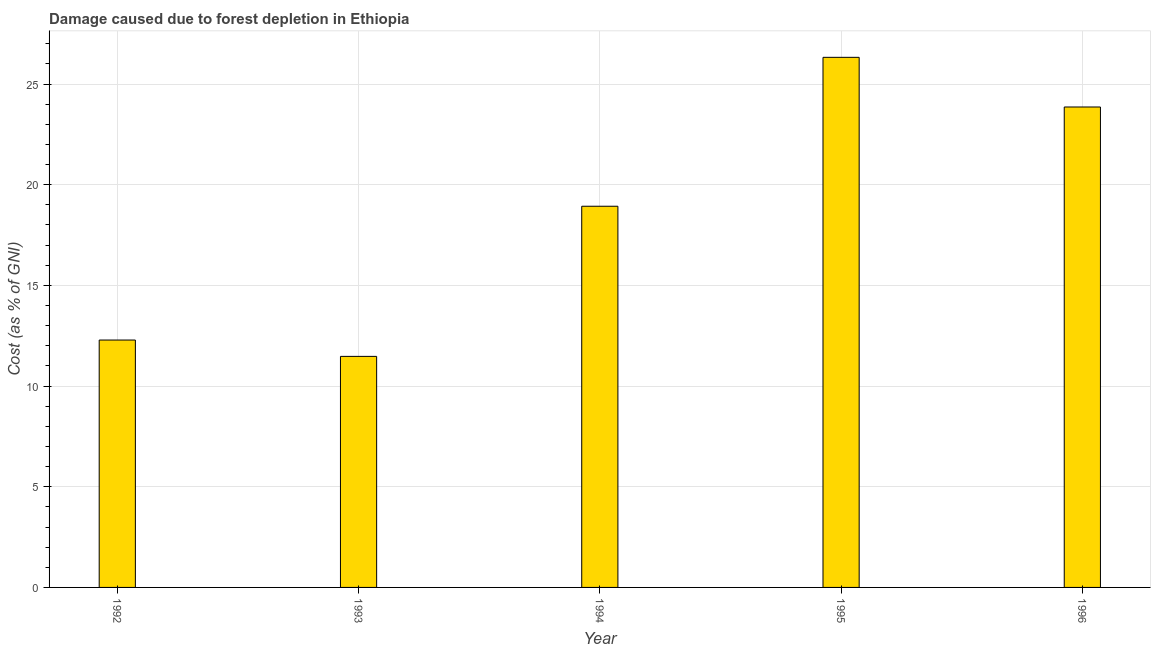Does the graph contain grids?
Offer a terse response. Yes. What is the title of the graph?
Ensure brevity in your answer.  Damage caused due to forest depletion in Ethiopia. What is the label or title of the X-axis?
Your response must be concise. Year. What is the label or title of the Y-axis?
Your response must be concise. Cost (as % of GNI). What is the damage caused due to forest depletion in 1995?
Your response must be concise. 26.33. Across all years, what is the maximum damage caused due to forest depletion?
Give a very brief answer. 26.33. Across all years, what is the minimum damage caused due to forest depletion?
Provide a succinct answer. 11.47. In which year was the damage caused due to forest depletion maximum?
Provide a short and direct response. 1995. In which year was the damage caused due to forest depletion minimum?
Make the answer very short. 1993. What is the sum of the damage caused due to forest depletion?
Provide a short and direct response. 92.88. What is the difference between the damage caused due to forest depletion in 1993 and 1996?
Offer a very short reply. -12.39. What is the average damage caused due to forest depletion per year?
Offer a very short reply. 18.58. What is the median damage caused due to forest depletion?
Your response must be concise. 18.93. Do a majority of the years between 1995 and 1996 (inclusive) have damage caused due to forest depletion greater than 25 %?
Offer a terse response. No. What is the ratio of the damage caused due to forest depletion in 1992 to that in 1993?
Offer a terse response. 1.07. Is the difference between the damage caused due to forest depletion in 1995 and 1996 greater than the difference between any two years?
Provide a succinct answer. No. What is the difference between the highest and the second highest damage caused due to forest depletion?
Your answer should be compact. 2.47. Is the sum of the damage caused due to forest depletion in 1992 and 1996 greater than the maximum damage caused due to forest depletion across all years?
Keep it short and to the point. Yes. What is the difference between the highest and the lowest damage caused due to forest depletion?
Your answer should be compact. 14.85. How many bars are there?
Ensure brevity in your answer.  5. Are all the bars in the graph horizontal?
Make the answer very short. No. How many years are there in the graph?
Your response must be concise. 5. What is the Cost (as % of GNI) of 1992?
Your response must be concise. 12.29. What is the Cost (as % of GNI) of 1993?
Your response must be concise. 11.47. What is the Cost (as % of GNI) in 1994?
Make the answer very short. 18.93. What is the Cost (as % of GNI) of 1995?
Keep it short and to the point. 26.33. What is the Cost (as % of GNI) in 1996?
Make the answer very short. 23.86. What is the difference between the Cost (as % of GNI) in 1992 and 1993?
Your answer should be very brief. 0.81. What is the difference between the Cost (as % of GNI) in 1992 and 1994?
Offer a very short reply. -6.65. What is the difference between the Cost (as % of GNI) in 1992 and 1995?
Give a very brief answer. -14.04. What is the difference between the Cost (as % of GNI) in 1992 and 1996?
Give a very brief answer. -11.57. What is the difference between the Cost (as % of GNI) in 1993 and 1994?
Give a very brief answer. -7.46. What is the difference between the Cost (as % of GNI) in 1993 and 1995?
Your answer should be compact. -14.85. What is the difference between the Cost (as % of GNI) in 1993 and 1996?
Provide a succinct answer. -12.39. What is the difference between the Cost (as % of GNI) in 1994 and 1995?
Your answer should be compact. -7.4. What is the difference between the Cost (as % of GNI) in 1994 and 1996?
Provide a short and direct response. -4.93. What is the difference between the Cost (as % of GNI) in 1995 and 1996?
Provide a short and direct response. 2.47. What is the ratio of the Cost (as % of GNI) in 1992 to that in 1993?
Offer a very short reply. 1.07. What is the ratio of the Cost (as % of GNI) in 1992 to that in 1994?
Your response must be concise. 0.65. What is the ratio of the Cost (as % of GNI) in 1992 to that in 1995?
Ensure brevity in your answer.  0.47. What is the ratio of the Cost (as % of GNI) in 1992 to that in 1996?
Give a very brief answer. 0.52. What is the ratio of the Cost (as % of GNI) in 1993 to that in 1994?
Your answer should be compact. 0.61. What is the ratio of the Cost (as % of GNI) in 1993 to that in 1995?
Provide a short and direct response. 0.44. What is the ratio of the Cost (as % of GNI) in 1993 to that in 1996?
Provide a succinct answer. 0.48. What is the ratio of the Cost (as % of GNI) in 1994 to that in 1995?
Your response must be concise. 0.72. What is the ratio of the Cost (as % of GNI) in 1994 to that in 1996?
Offer a very short reply. 0.79. What is the ratio of the Cost (as % of GNI) in 1995 to that in 1996?
Make the answer very short. 1.1. 